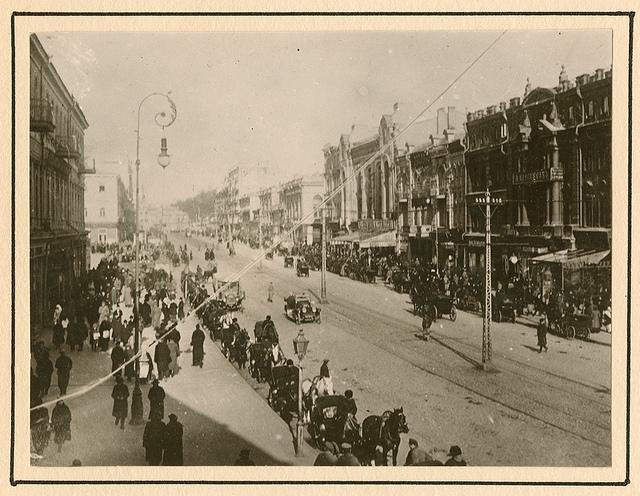Is this a brand new photo?
Answer briefly. No. What style of photo is this?
Write a very short answer. Black and white. What is the long thing object hanging across this scene?
Short answer required. Rope. Are there trees lining the street?
Be succinct. No. This photo was taken during what century?
Write a very short answer. 20th. 